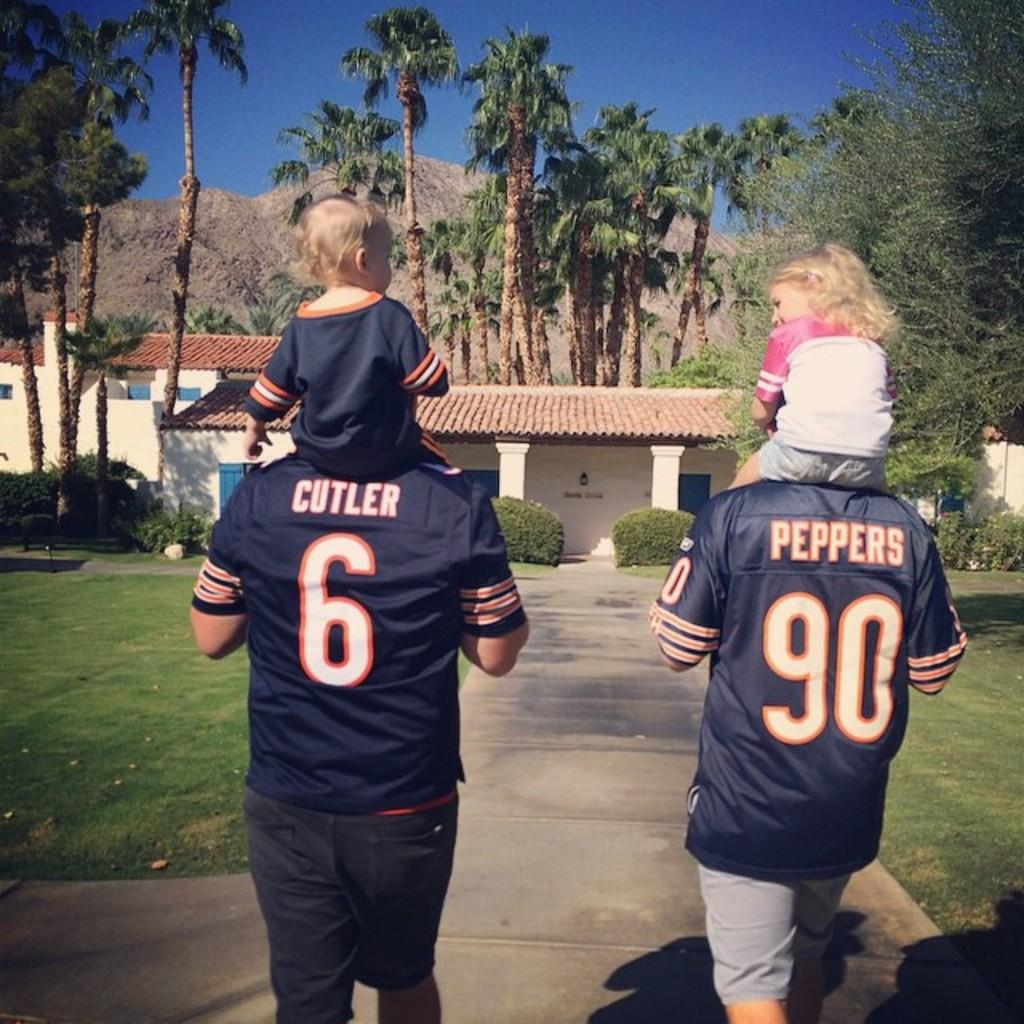<image>
Give a short and clear explanation of the subsequent image. Jerseys with Cutler and Peppers designed on the back. 